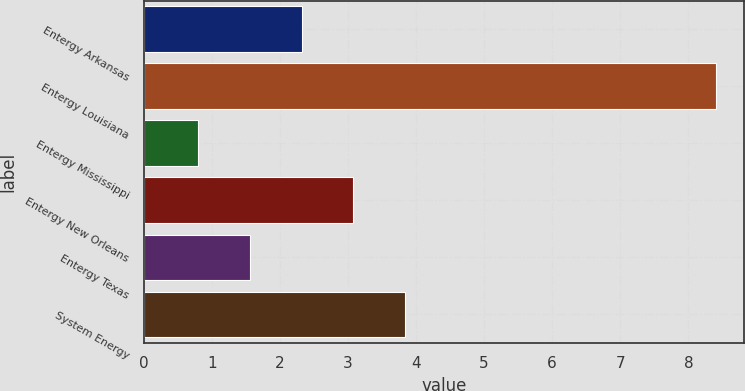<chart> <loc_0><loc_0><loc_500><loc_500><bar_chart><fcel>Entergy Arkansas<fcel>Entergy Louisiana<fcel>Entergy Mississippi<fcel>Entergy New Orleans<fcel>Entergy Texas<fcel>System Energy<nl><fcel>2.32<fcel>8.4<fcel>0.8<fcel>3.08<fcel>1.56<fcel>3.84<nl></chart> 